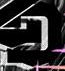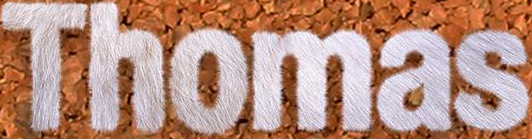What words are shown in these images in order, separated by a semicolon? D; Thomas 